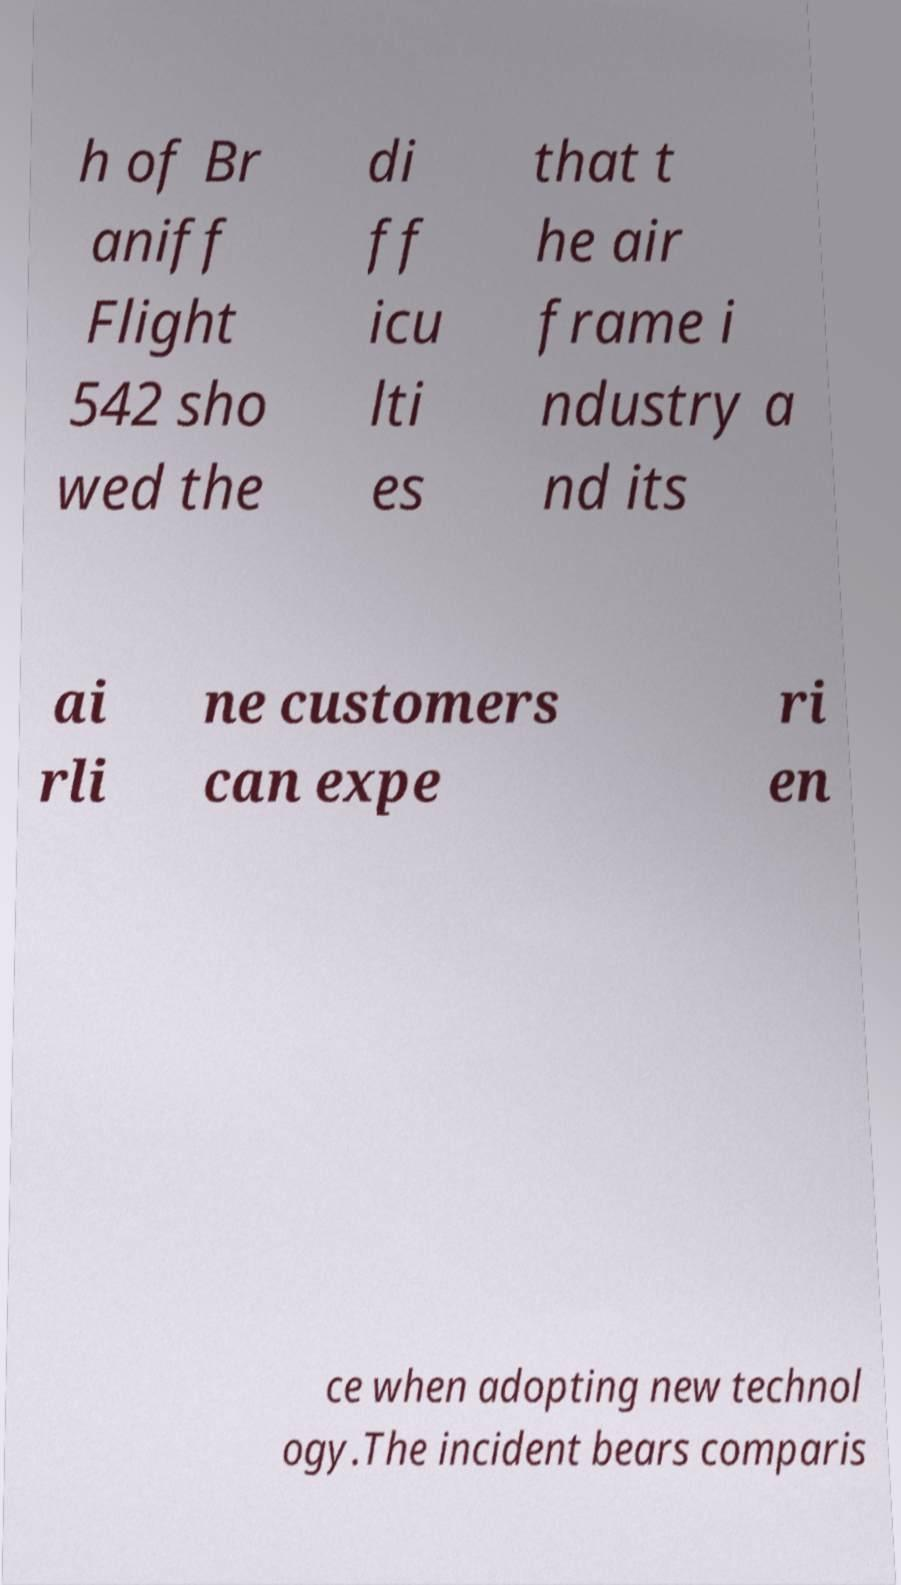Please identify and transcribe the text found in this image. h of Br aniff Flight 542 sho wed the di ff icu lti es that t he air frame i ndustry a nd its ai rli ne customers can expe ri en ce when adopting new technol ogy.The incident bears comparis 